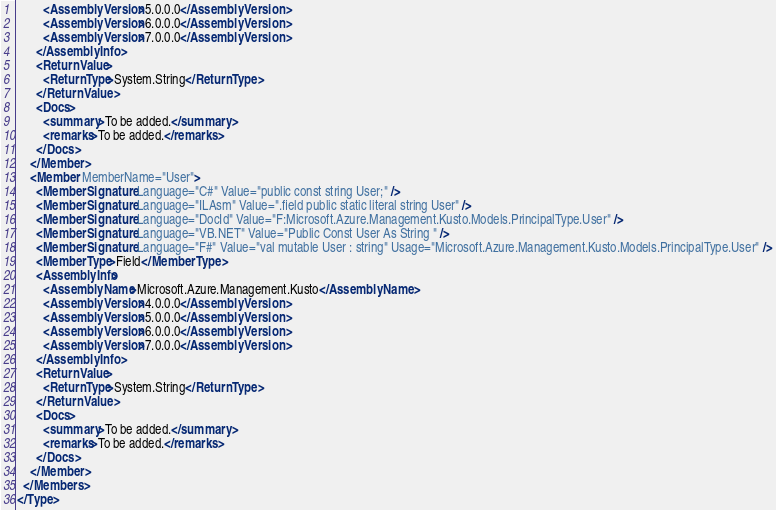<code> <loc_0><loc_0><loc_500><loc_500><_XML_>        <AssemblyVersion>5.0.0.0</AssemblyVersion>
        <AssemblyVersion>6.0.0.0</AssemblyVersion>
        <AssemblyVersion>7.0.0.0</AssemblyVersion>
      </AssemblyInfo>
      <ReturnValue>
        <ReturnType>System.String</ReturnType>
      </ReturnValue>
      <Docs>
        <summary>To be added.</summary>
        <remarks>To be added.</remarks>
      </Docs>
    </Member>
    <Member MemberName="User">
      <MemberSignature Language="C#" Value="public const string User;" />
      <MemberSignature Language="ILAsm" Value=".field public static literal string User" />
      <MemberSignature Language="DocId" Value="F:Microsoft.Azure.Management.Kusto.Models.PrincipalType.User" />
      <MemberSignature Language="VB.NET" Value="Public Const User As String " />
      <MemberSignature Language="F#" Value="val mutable User : string" Usage="Microsoft.Azure.Management.Kusto.Models.PrincipalType.User" />
      <MemberType>Field</MemberType>
      <AssemblyInfo>
        <AssemblyName>Microsoft.Azure.Management.Kusto</AssemblyName>
        <AssemblyVersion>4.0.0.0</AssemblyVersion>
        <AssemblyVersion>5.0.0.0</AssemblyVersion>
        <AssemblyVersion>6.0.0.0</AssemblyVersion>
        <AssemblyVersion>7.0.0.0</AssemblyVersion>
      </AssemblyInfo>
      <ReturnValue>
        <ReturnType>System.String</ReturnType>
      </ReturnValue>
      <Docs>
        <summary>To be added.</summary>
        <remarks>To be added.</remarks>
      </Docs>
    </Member>
  </Members>
</Type>
</code> 